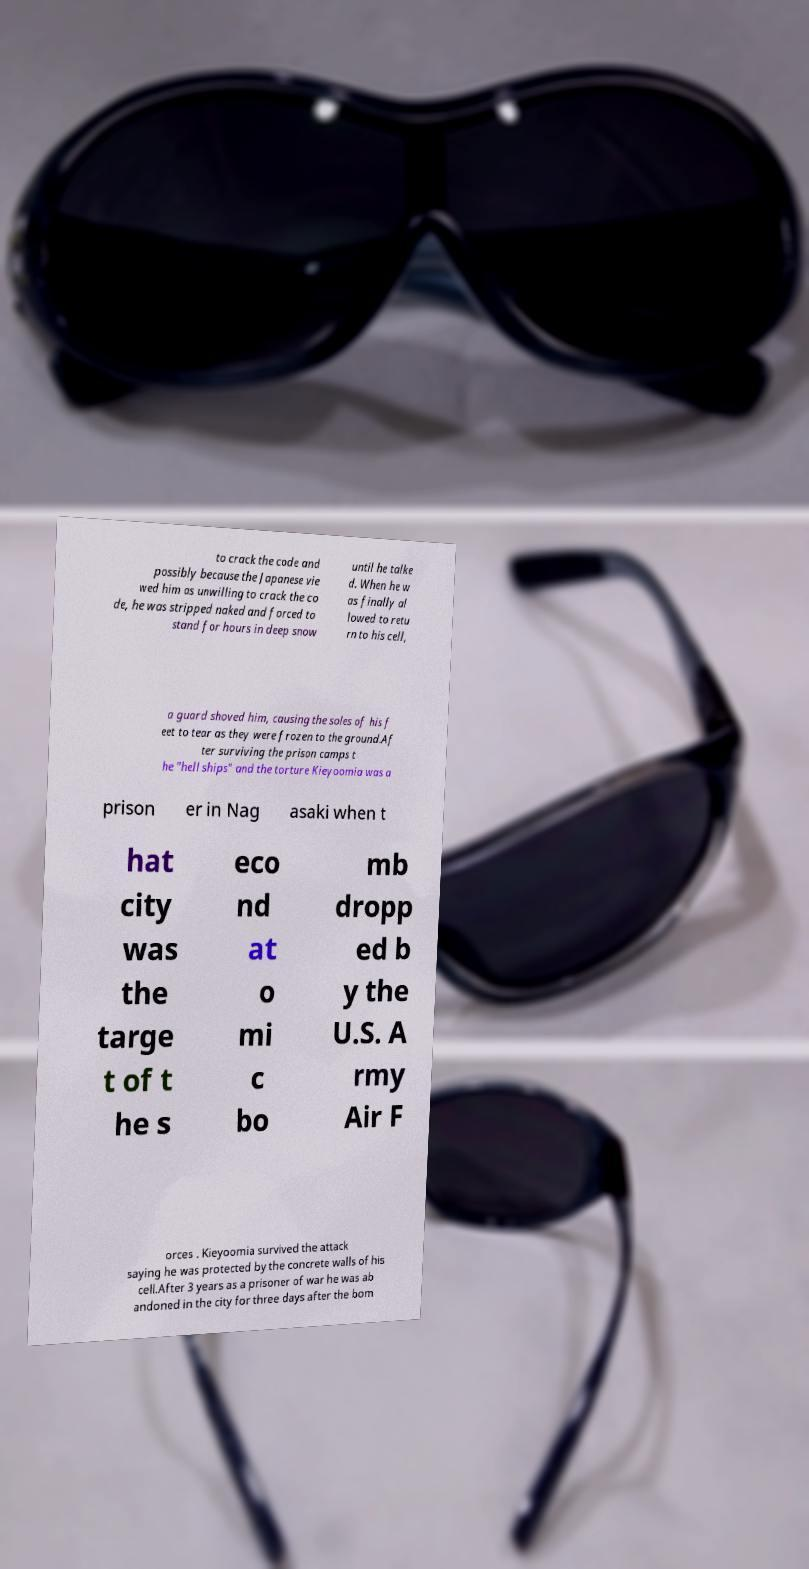What messages or text are displayed in this image? I need them in a readable, typed format. to crack the code and possibly because the Japanese vie wed him as unwilling to crack the co de, he was stripped naked and forced to stand for hours in deep snow until he talke d. When he w as finally al lowed to retu rn to his cell, a guard shoved him, causing the soles of his f eet to tear as they were frozen to the ground.Af ter surviving the prison camps t he "hell ships" and the torture Kieyoomia was a prison er in Nag asaki when t hat city was the targe t of t he s eco nd at o mi c bo mb dropp ed b y the U.S. A rmy Air F orces . Kieyoomia survived the attack saying he was protected by the concrete walls of his cell.After 3 years as a prisoner of war he was ab andoned in the city for three days after the bom 